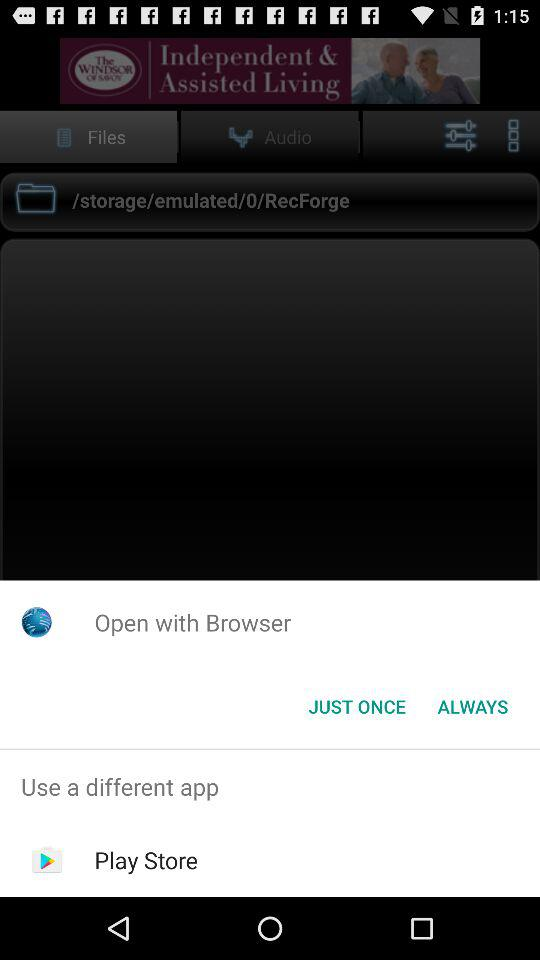What different apps can we use? The different app you can use is Play Store. 